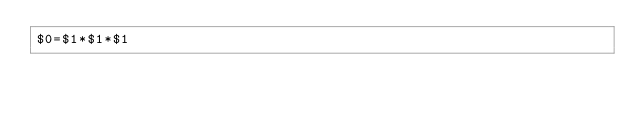Convert code to text. <code><loc_0><loc_0><loc_500><loc_500><_Awk_>$0=$1*$1*$1</code> 